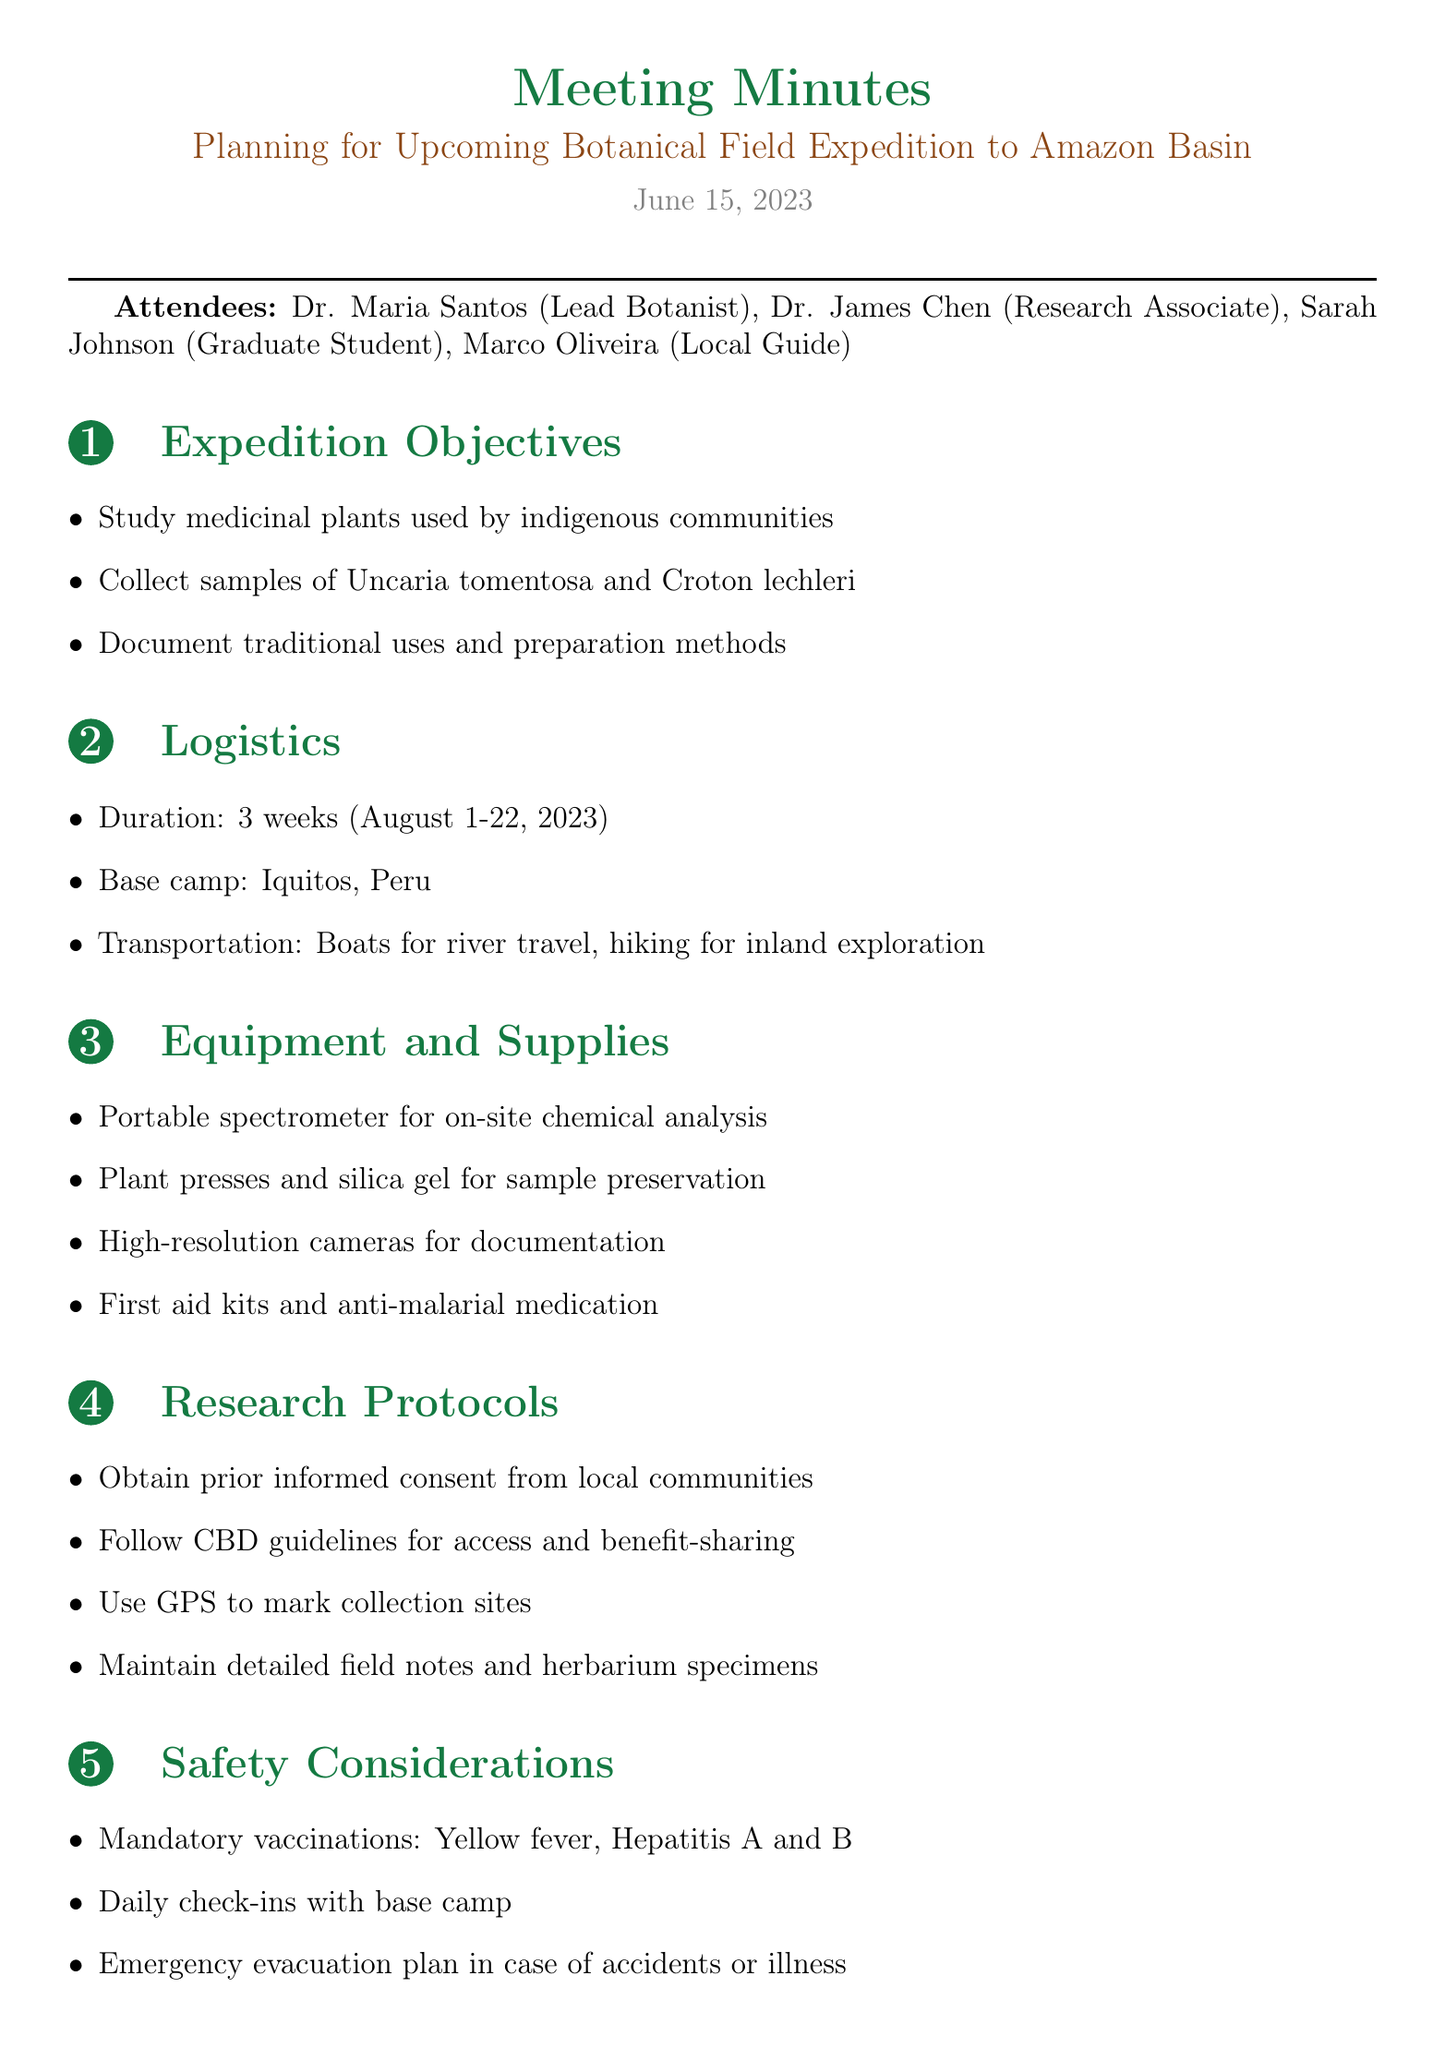what are the expedition dates? The expedition is scheduled from August 1 to August 22, 2023.
Answer: August 1-22, 2023 who is the lead botanist? The lead botanist is Dr. Maria Santos.
Answer: Dr. Maria Santos which medicinal plants are planned to be collected? The plants to be collected include Uncaria tomentosa and Croton lechleri.
Answer: Uncaria tomentosa and Croton lechleri what is the base camp location? The base camp for the expedition will be set up in Iquitos, Peru.
Answer: Iquitos, Peru what protocols are to be followed for research? Research protocols include obtaining prior informed consent and following CBD guidelines.
Answer: Obtain prior informed consent, follow CBD guidelines how long is the expedition planned to last? The expedition is planned to last for 3 weeks.
Answer: 3 weeks who is responsible for coordinating with local communities? Marco Oliveira is responsible for coordinating with local communities for site visits.
Answer: Marco Oliveira what is the primary focus of the post-expedition plans? The primary focus includes analysis of collected samples at the University of São Paulo.
Answer: Analysis of collected samples at University of São Paulo 